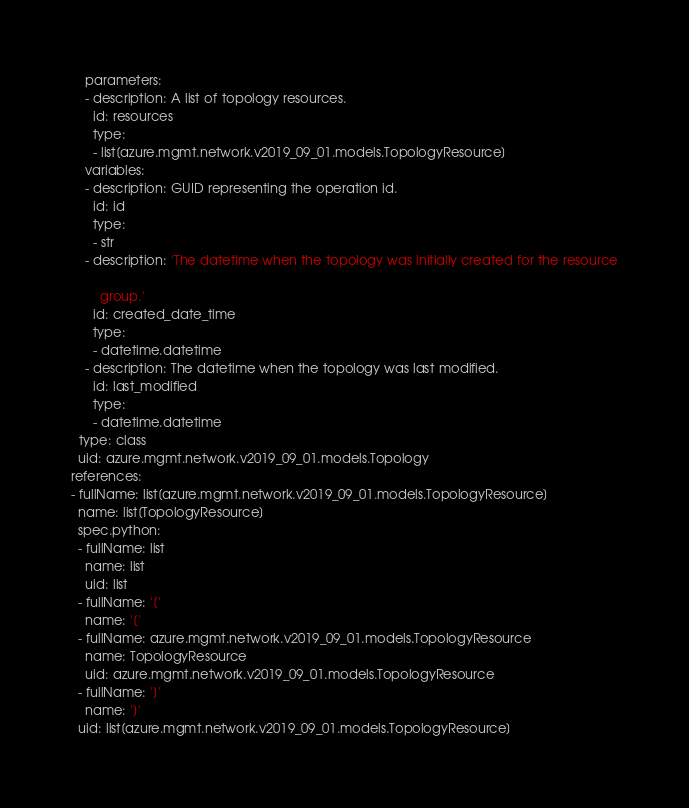Convert code to text. <code><loc_0><loc_0><loc_500><loc_500><_YAML_>    parameters:
    - description: A list of topology resources.
      id: resources
      type:
      - list[azure.mgmt.network.v2019_09_01.models.TopologyResource]
    variables:
    - description: GUID representing the operation id.
      id: id
      type:
      - str
    - description: 'The datetime when the topology was initially created for the resource

        group.'
      id: created_date_time
      type:
      - datetime.datetime
    - description: The datetime when the topology was last modified.
      id: last_modified
      type:
      - datetime.datetime
  type: class
  uid: azure.mgmt.network.v2019_09_01.models.Topology
references:
- fullName: list[azure.mgmt.network.v2019_09_01.models.TopologyResource]
  name: list[TopologyResource]
  spec.python:
  - fullName: list
    name: list
    uid: list
  - fullName: '['
    name: '['
  - fullName: azure.mgmt.network.v2019_09_01.models.TopologyResource
    name: TopologyResource
    uid: azure.mgmt.network.v2019_09_01.models.TopologyResource
  - fullName: ']'
    name: ']'
  uid: list[azure.mgmt.network.v2019_09_01.models.TopologyResource]
</code> 